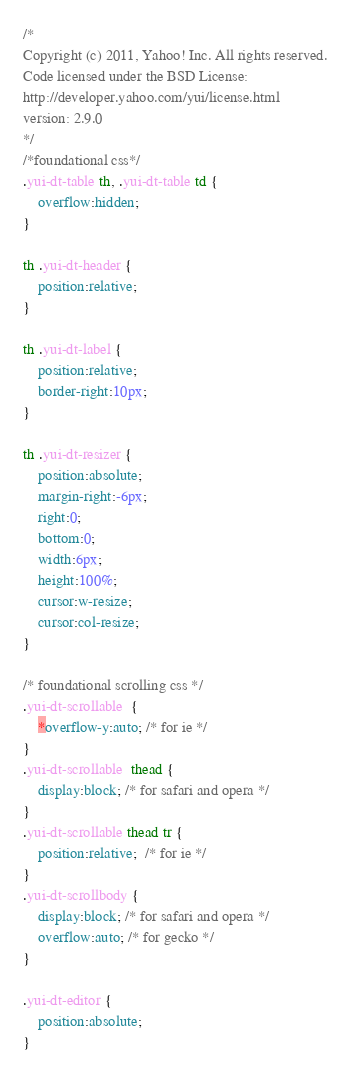Convert code to text. <code><loc_0><loc_0><loc_500><loc_500><_CSS_>/*
Copyright (c) 2011, Yahoo! Inc. All rights reserved.
Code licensed under the BSD License:
http://developer.yahoo.com/yui/license.html
version: 2.9.0
*/
/*foundational css*/
.yui-dt-table th, .yui-dt-table td {
    overflow:hidden;
}

th .yui-dt-header {
    position:relative;
}

th .yui-dt-label {
    position:relative;
    border-right:10px;
}

th .yui-dt-resizer {
    position:absolute;
    margin-right:-6px;
    right:0;
    bottom:0;
    width:6px;
    height:100%;
    cursor:w-resize;
    cursor:col-resize;
}

/* foundational scrolling css */
.yui-dt-scrollable  {
    *overflow-y:auto; /* for ie */
}
.yui-dt-scrollable  thead {
    display:block; /* for safari and opera */
}
.yui-dt-scrollable thead tr {
    position:relative;  /* for ie */
}
.yui-dt-scrollbody {
    display:block; /* for safari and opera */
    overflow:auto; /* for gecko */
}

.yui-dt-editor {
    position:absolute;
}
</code> 